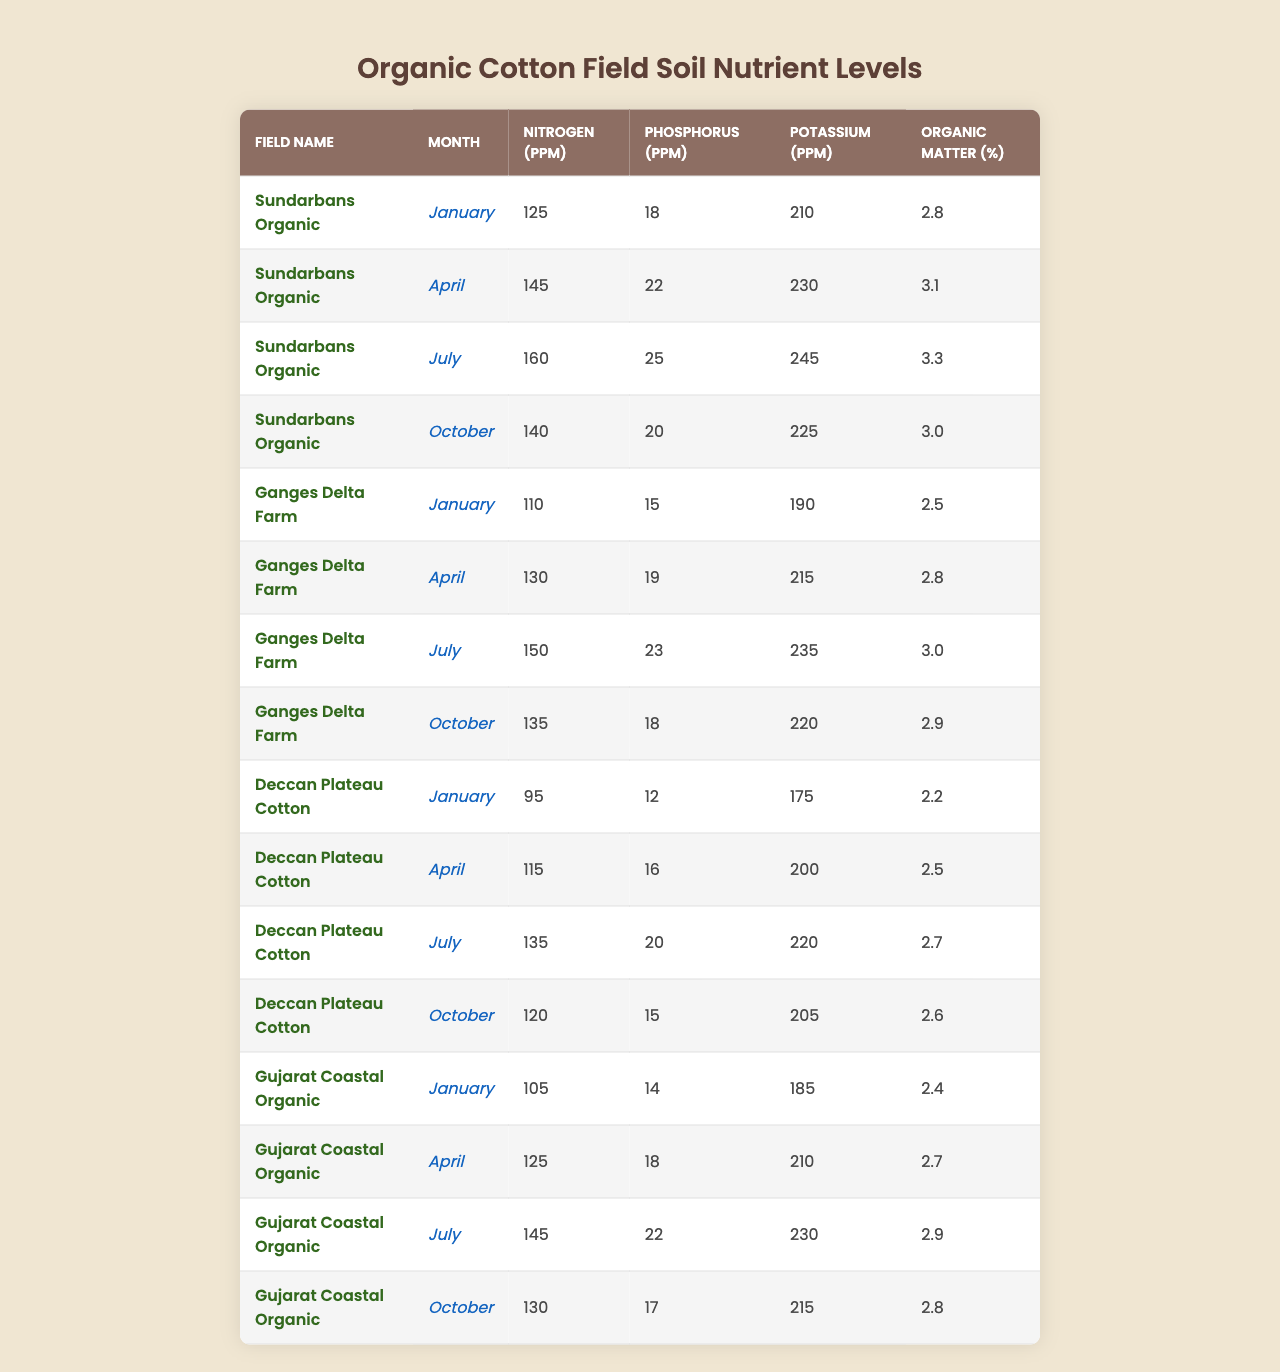What is the nitrogen level in Sundarbans Organic for July? Looking at the row for Sundarbans Organic in July, the nitrogen level is 160 ppm.
Answer: 160 ppm What is the phosphorus level in Ganges Delta Farm for October? In the table, the row for Ganges Delta Farm in October shows a phosphorus level of 18 ppm.
Answer: 18 ppm Which field had the highest potassium level in January? Checking the potassium levels in January for each field: Sundarbans Organic has 210 ppm, Ganges Delta Farm has 190 ppm, Deccan Plateau Cotton has 175 ppm, and Gujarat Coastal Organic has 185 ppm. The highest is 210 ppm from Sundarbans Organic.
Answer: Sundarbans Organic What is the average organic matter percentage across all fields in April? The organic matter percentages for April are 3.1, 2.8, 2.5, and 2.7. Adding these gives 11.1, and dividing by 4 (number of fields) gives us an average of 2.775%.
Answer: 2.775% Is the nitrogen level in Deccan Plateau Cotton in July greater than 130 ppm? The nitrogen level for Deccan Plateau Cotton in July is 135 ppm, which is greater than 130 ppm.
Answer: Yes Which month has the highest nitrogen level across all fields? Comparing nitrogen levels across all months, the highest value is found in July at 160 ppm from Sundarbans Organic.
Answer: July What is the change in potassium levels in Gujarat Coastal Organic from January to October? In January, the potassium level is 185 ppm and in October, it's 215 ppm. The change is 215 - 185 = 30 ppm increase.
Answer: 30 ppm increase How does the average nitrogen level in Ganges Delta Farm compare between April and October? The nitrogen levels are 130 ppm in April and 135 ppm in October. The average is (130 + 135) / 2 = 132.5 ppm, and October's level is higher than April's.
Answer: Higher in October Which field shows the most significant increase in nitrogen from January to July? For Sundarbans Organic, nitrogen increases from 125 ppm in January to 160 ppm in July (35 ppm increase). For Ganges Delta Farm, from 110 to 150 ppm (40 ppm increase), and for Deccan Plateau Cotton, from 95 to 135 ppm (40 ppm increase). Both Ganges Delta Farm and Deccan Plateau Cotton each show a 40 ppm increase, but Sundarbans has the highest growth percentage calculated as (35/125)*100 = 28%.
Answer: Ganges Delta Farm and Deccan Plateau Cotton (40 ppm increase) Is it true that all fields have potassium levels above 200 ppm in October? Checking the potassium levels in October: Sundarbans Organic has 225 ppm, Ganges Delta Farm has 220 ppm, Deccan Plateau Cotton has 205 ppm, and Gujarat Coastal Organic has 215 ppm. All are above 200 ppm.
Answer: Yes 